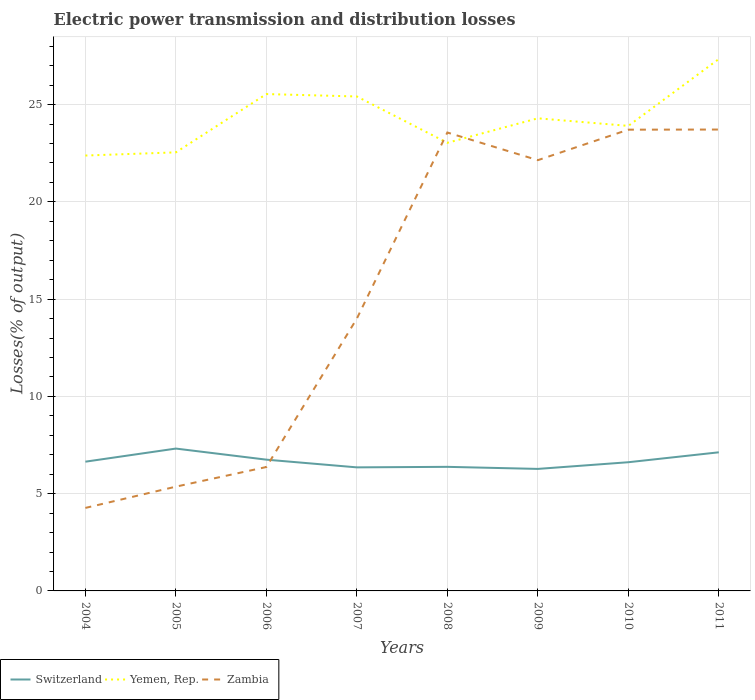How many different coloured lines are there?
Your answer should be very brief. 3. Does the line corresponding to Yemen, Rep. intersect with the line corresponding to Switzerland?
Your response must be concise. No. Is the number of lines equal to the number of legend labels?
Give a very brief answer. Yes. Across all years, what is the maximum electric power transmission and distribution losses in Zambia?
Your answer should be very brief. 4.27. In which year was the electric power transmission and distribution losses in Zambia maximum?
Offer a terse response. 2004. What is the total electric power transmission and distribution losses in Switzerland in the graph?
Provide a short and direct response. -0.67. What is the difference between the highest and the second highest electric power transmission and distribution losses in Zambia?
Offer a terse response. 19.45. Does the graph contain any zero values?
Your answer should be compact. No. How are the legend labels stacked?
Your response must be concise. Horizontal. What is the title of the graph?
Make the answer very short. Electric power transmission and distribution losses. Does "St. Kitts and Nevis" appear as one of the legend labels in the graph?
Give a very brief answer. No. What is the label or title of the Y-axis?
Your answer should be very brief. Losses(% of output). What is the Losses(% of output) in Switzerland in 2004?
Provide a short and direct response. 6.64. What is the Losses(% of output) in Yemen, Rep. in 2004?
Provide a short and direct response. 22.38. What is the Losses(% of output) in Zambia in 2004?
Your response must be concise. 4.27. What is the Losses(% of output) of Switzerland in 2005?
Your answer should be very brief. 7.32. What is the Losses(% of output) of Yemen, Rep. in 2005?
Your response must be concise. 22.55. What is the Losses(% of output) of Zambia in 2005?
Ensure brevity in your answer.  5.36. What is the Losses(% of output) of Switzerland in 2006?
Your answer should be very brief. 6.75. What is the Losses(% of output) in Yemen, Rep. in 2006?
Ensure brevity in your answer.  25.54. What is the Losses(% of output) of Zambia in 2006?
Provide a short and direct response. 6.37. What is the Losses(% of output) in Switzerland in 2007?
Your answer should be compact. 6.35. What is the Losses(% of output) of Yemen, Rep. in 2007?
Ensure brevity in your answer.  25.42. What is the Losses(% of output) in Zambia in 2007?
Provide a short and direct response. 14. What is the Losses(% of output) of Switzerland in 2008?
Make the answer very short. 6.38. What is the Losses(% of output) in Yemen, Rep. in 2008?
Provide a short and direct response. 23.04. What is the Losses(% of output) in Zambia in 2008?
Your answer should be compact. 23.57. What is the Losses(% of output) of Switzerland in 2009?
Your answer should be compact. 6.27. What is the Losses(% of output) of Yemen, Rep. in 2009?
Ensure brevity in your answer.  24.3. What is the Losses(% of output) of Zambia in 2009?
Keep it short and to the point. 22.14. What is the Losses(% of output) of Switzerland in 2010?
Keep it short and to the point. 6.62. What is the Losses(% of output) of Yemen, Rep. in 2010?
Ensure brevity in your answer.  23.91. What is the Losses(% of output) in Zambia in 2010?
Offer a very short reply. 23.71. What is the Losses(% of output) of Switzerland in 2011?
Ensure brevity in your answer.  7.13. What is the Losses(% of output) in Yemen, Rep. in 2011?
Give a very brief answer. 27.34. What is the Losses(% of output) of Zambia in 2011?
Provide a short and direct response. 23.72. Across all years, what is the maximum Losses(% of output) in Switzerland?
Provide a short and direct response. 7.32. Across all years, what is the maximum Losses(% of output) in Yemen, Rep.?
Provide a succinct answer. 27.34. Across all years, what is the maximum Losses(% of output) of Zambia?
Offer a terse response. 23.72. Across all years, what is the minimum Losses(% of output) of Switzerland?
Provide a succinct answer. 6.27. Across all years, what is the minimum Losses(% of output) of Yemen, Rep.?
Ensure brevity in your answer.  22.38. Across all years, what is the minimum Losses(% of output) of Zambia?
Your response must be concise. 4.27. What is the total Losses(% of output) in Switzerland in the graph?
Provide a short and direct response. 53.46. What is the total Losses(% of output) of Yemen, Rep. in the graph?
Your answer should be compact. 194.48. What is the total Losses(% of output) in Zambia in the graph?
Offer a terse response. 123.14. What is the difference between the Losses(% of output) in Switzerland in 2004 and that in 2005?
Your response must be concise. -0.67. What is the difference between the Losses(% of output) of Yemen, Rep. in 2004 and that in 2005?
Make the answer very short. -0.16. What is the difference between the Losses(% of output) in Zambia in 2004 and that in 2005?
Give a very brief answer. -1.09. What is the difference between the Losses(% of output) in Switzerland in 2004 and that in 2006?
Your answer should be compact. -0.1. What is the difference between the Losses(% of output) of Yemen, Rep. in 2004 and that in 2006?
Give a very brief answer. -3.16. What is the difference between the Losses(% of output) of Zambia in 2004 and that in 2006?
Your response must be concise. -2.1. What is the difference between the Losses(% of output) of Switzerland in 2004 and that in 2007?
Make the answer very short. 0.29. What is the difference between the Losses(% of output) of Yemen, Rep. in 2004 and that in 2007?
Give a very brief answer. -3.04. What is the difference between the Losses(% of output) in Zambia in 2004 and that in 2007?
Your response must be concise. -9.74. What is the difference between the Losses(% of output) of Switzerland in 2004 and that in 2008?
Provide a short and direct response. 0.27. What is the difference between the Losses(% of output) of Yemen, Rep. in 2004 and that in 2008?
Give a very brief answer. -0.65. What is the difference between the Losses(% of output) in Zambia in 2004 and that in 2008?
Your answer should be compact. -19.3. What is the difference between the Losses(% of output) in Switzerland in 2004 and that in 2009?
Your response must be concise. 0.37. What is the difference between the Losses(% of output) of Yemen, Rep. in 2004 and that in 2009?
Offer a very short reply. -1.91. What is the difference between the Losses(% of output) in Zambia in 2004 and that in 2009?
Provide a short and direct response. -17.88. What is the difference between the Losses(% of output) of Switzerland in 2004 and that in 2010?
Make the answer very short. 0.03. What is the difference between the Losses(% of output) in Yemen, Rep. in 2004 and that in 2010?
Ensure brevity in your answer.  -1.52. What is the difference between the Losses(% of output) of Zambia in 2004 and that in 2010?
Ensure brevity in your answer.  -19.45. What is the difference between the Losses(% of output) of Switzerland in 2004 and that in 2011?
Provide a short and direct response. -0.48. What is the difference between the Losses(% of output) in Yemen, Rep. in 2004 and that in 2011?
Give a very brief answer. -4.96. What is the difference between the Losses(% of output) in Zambia in 2004 and that in 2011?
Keep it short and to the point. -19.45. What is the difference between the Losses(% of output) of Switzerland in 2005 and that in 2006?
Your response must be concise. 0.57. What is the difference between the Losses(% of output) of Yemen, Rep. in 2005 and that in 2006?
Provide a short and direct response. -3. What is the difference between the Losses(% of output) of Zambia in 2005 and that in 2006?
Keep it short and to the point. -1.01. What is the difference between the Losses(% of output) in Switzerland in 2005 and that in 2007?
Offer a very short reply. 0.97. What is the difference between the Losses(% of output) of Yemen, Rep. in 2005 and that in 2007?
Provide a succinct answer. -2.87. What is the difference between the Losses(% of output) of Zambia in 2005 and that in 2007?
Provide a succinct answer. -8.64. What is the difference between the Losses(% of output) of Switzerland in 2005 and that in 2008?
Keep it short and to the point. 0.94. What is the difference between the Losses(% of output) in Yemen, Rep. in 2005 and that in 2008?
Your answer should be very brief. -0.49. What is the difference between the Losses(% of output) in Zambia in 2005 and that in 2008?
Provide a short and direct response. -18.21. What is the difference between the Losses(% of output) in Switzerland in 2005 and that in 2009?
Provide a short and direct response. 1.05. What is the difference between the Losses(% of output) in Yemen, Rep. in 2005 and that in 2009?
Provide a succinct answer. -1.75. What is the difference between the Losses(% of output) in Zambia in 2005 and that in 2009?
Your answer should be compact. -16.78. What is the difference between the Losses(% of output) in Switzerland in 2005 and that in 2010?
Your response must be concise. 0.7. What is the difference between the Losses(% of output) of Yemen, Rep. in 2005 and that in 2010?
Provide a short and direct response. -1.36. What is the difference between the Losses(% of output) in Zambia in 2005 and that in 2010?
Keep it short and to the point. -18.35. What is the difference between the Losses(% of output) of Switzerland in 2005 and that in 2011?
Provide a short and direct response. 0.19. What is the difference between the Losses(% of output) in Yemen, Rep. in 2005 and that in 2011?
Your answer should be very brief. -4.8. What is the difference between the Losses(% of output) of Zambia in 2005 and that in 2011?
Offer a very short reply. -18.36. What is the difference between the Losses(% of output) in Switzerland in 2006 and that in 2007?
Give a very brief answer. 0.4. What is the difference between the Losses(% of output) in Yemen, Rep. in 2006 and that in 2007?
Your answer should be compact. 0.12. What is the difference between the Losses(% of output) in Zambia in 2006 and that in 2007?
Offer a very short reply. -7.63. What is the difference between the Losses(% of output) of Switzerland in 2006 and that in 2008?
Offer a terse response. 0.37. What is the difference between the Losses(% of output) in Yemen, Rep. in 2006 and that in 2008?
Your answer should be compact. 2.51. What is the difference between the Losses(% of output) in Zambia in 2006 and that in 2008?
Offer a very short reply. -17.2. What is the difference between the Losses(% of output) of Switzerland in 2006 and that in 2009?
Offer a very short reply. 0.48. What is the difference between the Losses(% of output) of Yemen, Rep. in 2006 and that in 2009?
Your answer should be very brief. 1.25. What is the difference between the Losses(% of output) in Zambia in 2006 and that in 2009?
Offer a very short reply. -15.77. What is the difference between the Losses(% of output) in Switzerland in 2006 and that in 2010?
Your answer should be compact. 0.13. What is the difference between the Losses(% of output) of Yemen, Rep. in 2006 and that in 2010?
Ensure brevity in your answer.  1.64. What is the difference between the Losses(% of output) of Zambia in 2006 and that in 2010?
Offer a very short reply. -17.34. What is the difference between the Losses(% of output) of Switzerland in 2006 and that in 2011?
Your answer should be compact. -0.38. What is the difference between the Losses(% of output) of Yemen, Rep. in 2006 and that in 2011?
Make the answer very short. -1.8. What is the difference between the Losses(% of output) in Zambia in 2006 and that in 2011?
Provide a short and direct response. -17.35. What is the difference between the Losses(% of output) of Switzerland in 2007 and that in 2008?
Ensure brevity in your answer.  -0.03. What is the difference between the Losses(% of output) of Yemen, Rep. in 2007 and that in 2008?
Provide a succinct answer. 2.38. What is the difference between the Losses(% of output) in Zambia in 2007 and that in 2008?
Provide a short and direct response. -9.56. What is the difference between the Losses(% of output) in Switzerland in 2007 and that in 2009?
Offer a very short reply. 0.08. What is the difference between the Losses(% of output) of Yemen, Rep. in 2007 and that in 2009?
Provide a succinct answer. 1.12. What is the difference between the Losses(% of output) in Zambia in 2007 and that in 2009?
Keep it short and to the point. -8.14. What is the difference between the Losses(% of output) of Switzerland in 2007 and that in 2010?
Your answer should be compact. -0.26. What is the difference between the Losses(% of output) of Yemen, Rep. in 2007 and that in 2010?
Offer a terse response. 1.51. What is the difference between the Losses(% of output) of Zambia in 2007 and that in 2010?
Ensure brevity in your answer.  -9.71. What is the difference between the Losses(% of output) in Switzerland in 2007 and that in 2011?
Ensure brevity in your answer.  -0.77. What is the difference between the Losses(% of output) of Yemen, Rep. in 2007 and that in 2011?
Keep it short and to the point. -1.93. What is the difference between the Losses(% of output) in Zambia in 2007 and that in 2011?
Provide a succinct answer. -9.72. What is the difference between the Losses(% of output) in Switzerland in 2008 and that in 2009?
Keep it short and to the point. 0.11. What is the difference between the Losses(% of output) of Yemen, Rep. in 2008 and that in 2009?
Offer a very short reply. -1.26. What is the difference between the Losses(% of output) in Zambia in 2008 and that in 2009?
Provide a short and direct response. 1.42. What is the difference between the Losses(% of output) of Switzerland in 2008 and that in 2010?
Offer a terse response. -0.24. What is the difference between the Losses(% of output) of Yemen, Rep. in 2008 and that in 2010?
Give a very brief answer. -0.87. What is the difference between the Losses(% of output) of Zambia in 2008 and that in 2010?
Your answer should be very brief. -0.15. What is the difference between the Losses(% of output) of Switzerland in 2008 and that in 2011?
Ensure brevity in your answer.  -0.75. What is the difference between the Losses(% of output) in Yemen, Rep. in 2008 and that in 2011?
Your answer should be very brief. -4.31. What is the difference between the Losses(% of output) of Zambia in 2008 and that in 2011?
Ensure brevity in your answer.  -0.15. What is the difference between the Losses(% of output) in Switzerland in 2009 and that in 2010?
Your response must be concise. -0.34. What is the difference between the Losses(% of output) of Yemen, Rep. in 2009 and that in 2010?
Keep it short and to the point. 0.39. What is the difference between the Losses(% of output) in Zambia in 2009 and that in 2010?
Provide a succinct answer. -1.57. What is the difference between the Losses(% of output) of Switzerland in 2009 and that in 2011?
Ensure brevity in your answer.  -0.85. What is the difference between the Losses(% of output) of Yemen, Rep. in 2009 and that in 2011?
Keep it short and to the point. -3.05. What is the difference between the Losses(% of output) of Zambia in 2009 and that in 2011?
Keep it short and to the point. -1.57. What is the difference between the Losses(% of output) in Switzerland in 2010 and that in 2011?
Provide a short and direct response. -0.51. What is the difference between the Losses(% of output) in Yemen, Rep. in 2010 and that in 2011?
Give a very brief answer. -3.44. What is the difference between the Losses(% of output) in Zambia in 2010 and that in 2011?
Keep it short and to the point. -0.01. What is the difference between the Losses(% of output) of Switzerland in 2004 and the Losses(% of output) of Yemen, Rep. in 2005?
Your answer should be compact. -15.9. What is the difference between the Losses(% of output) in Switzerland in 2004 and the Losses(% of output) in Zambia in 2005?
Provide a succinct answer. 1.28. What is the difference between the Losses(% of output) of Yemen, Rep. in 2004 and the Losses(% of output) of Zambia in 2005?
Provide a succinct answer. 17.02. What is the difference between the Losses(% of output) in Switzerland in 2004 and the Losses(% of output) in Yemen, Rep. in 2006?
Keep it short and to the point. -18.9. What is the difference between the Losses(% of output) in Switzerland in 2004 and the Losses(% of output) in Zambia in 2006?
Provide a succinct answer. 0.27. What is the difference between the Losses(% of output) of Yemen, Rep. in 2004 and the Losses(% of output) of Zambia in 2006?
Offer a very short reply. 16.01. What is the difference between the Losses(% of output) of Switzerland in 2004 and the Losses(% of output) of Yemen, Rep. in 2007?
Your answer should be very brief. -18.77. What is the difference between the Losses(% of output) in Switzerland in 2004 and the Losses(% of output) in Zambia in 2007?
Ensure brevity in your answer.  -7.36. What is the difference between the Losses(% of output) in Yemen, Rep. in 2004 and the Losses(% of output) in Zambia in 2007?
Your response must be concise. 8.38. What is the difference between the Losses(% of output) in Switzerland in 2004 and the Losses(% of output) in Yemen, Rep. in 2008?
Keep it short and to the point. -16.39. What is the difference between the Losses(% of output) of Switzerland in 2004 and the Losses(% of output) of Zambia in 2008?
Ensure brevity in your answer.  -16.92. What is the difference between the Losses(% of output) in Yemen, Rep. in 2004 and the Losses(% of output) in Zambia in 2008?
Keep it short and to the point. -1.18. What is the difference between the Losses(% of output) in Switzerland in 2004 and the Losses(% of output) in Yemen, Rep. in 2009?
Ensure brevity in your answer.  -17.65. What is the difference between the Losses(% of output) in Switzerland in 2004 and the Losses(% of output) in Zambia in 2009?
Provide a succinct answer. -15.5. What is the difference between the Losses(% of output) in Yemen, Rep. in 2004 and the Losses(% of output) in Zambia in 2009?
Offer a terse response. 0.24. What is the difference between the Losses(% of output) of Switzerland in 2004 and the Losses(% of output) of Yemen, Rep. in 2010?
Give a very brief answer. -17.26. What is the difference between the Losses(% of output) in Switzerland in 2004 and the Losses(% of output) in Zambia in 2010?
Keep it short and to the point. -17.07. What is the difference between the Losses(% of output) of Yemen, Rep. in 2004 and the Losses(% of output) of Zambia in 2010?
Give a very brief answer. -1.33. What is the difference between the Losses(% of output) in Switzerland in 2004 and the Losses(% of output) in Yemen, Rep. in 2011?
Offer a very short reply. -20.7. What is the difference between the Losses(% of output) in Switzerland in 2004 and the Losses(% of output) in Zambia in 2011?
Keep it short and to the point. -17.08. What is the difference between the Losses(% of output) in Yemen, Rep. in 2004 and the Losses(% of output) in Zambia in 2011?
Ensure brevity in your answer.  -1.34. What is the difference between the Losses(% of output) in Switzerland in 2005 and the Losses(% of output) in Yemen, Rep. in 2006?
Your response must be concise. -18.22. What is the difference between the Losses(% of output) in Switzerland in 2005 and the Losses(% of output) in Zambia in 2006?
Your response must be concise. 0.95. What is the difference between the Losses(% of output) of Yemen, Rep. in 2005 and the Losses(% of output) of Zambia in 2006?
Provide a succinct answer. 16.18. What is the difference between the Losses(% of output) in Switzerland in 2005 and the Losses(% of output) in Yemen, Rep. in 2007?
Provide a short and direct response. -18.1. What is the difference between the Losses(% of output) of Switzerland in 2005 and the Losses(% of output) of Zambia in 2007?
Give a very brief answer. -6.68. What is the difference between the Losses(% of output) of Yemen, Rep. in 2005 and the Losses(% of output) of Zambia in 2007?
Your response must be concise. 8.54. What is the difference between the Losses(% of output) in Switzerland in 2005 and the Losses(% of output) in Yemen, Rep. in 2008?
Make the answer very short. -15.72. What is the difference between the Losses(% of output) in Switzerland in 2005 and the Losses(% of output) in Zambia in 2008?
Make the answer very short. -16.25. What is the difference between the Losses(% of output) in Yemen, Rep. in 2005 and the Losses(% of output) in Zambia in 2008?
Provide a succinct answer. -1.02. What is the difference between the Losses(% of output) in Switzerland in 2005 and the Losses(% of output) in Yemen, Rep. in 2009?
Your response must be concise. -16.98. What is the difference between the Losses(% of output) in Switzerland in 2005 and the Losses(% of output) in Zambia in 2009?
Your answer should be very brief. -14.83. What is the difference between the Losses(% of output) of Yemen, Rep. in 2005 and the Losses(% of output) of Zambia in 2009?
Provide a succinct answer. 0.4. What is the difference between the Losses(% of output) in Switzerland in 2005 and the Losses(% of output) in Yemen, Rep. in 2010?
Give a very brief answer. -16.59. What is the difference between the Losses(% of output) in Switzerland in 2005 and the Losses(% of output) in Zambia in 2010?
Your answer should be very brief. -16.39. What is the difference between the Losses(% of output) of Yemen, Rep. in 2005 and the Losses(% of output) of Zambia in 2010?
Your answer should be compact. -1.17. What is the difference between the Losses(% of output) of Switzerland in 2005 and the Losses(% of output) of Yemen, Rep. in 2011?
Offer a very short reply. -20.03. What is the difference between the Losses(% of output) of Switzerland in 2005 and the Losses(% of output) of Zambia in 2011?
Your answer should be very brief. -16.4. What is the difference between the Losses(% of output) in Yemen, Rep. in 2005 and the Losses(% of output) in Zambia in 2011?
Offer a terse response. -1.17. What is the difference between the Losses(% of output) of Switzerland in 2006 and the Losses(% of output) of Yemen, Rep. in 2007?
Offer a very short reply. -18.67. What is the difference between the Losses(% of output) in Switzerland in 2006 and the Losses(% of output) in Zambia in 2007?
Make the answer very short. -7.25. What is the difference between the Losses(% of output) in Yemen, Rep. in 2006 and the Losses(% of output) in Zambia in 2007?
Your answer should be compact. 11.54. What is the difference between the Losses(% of output) in Switzerland in 2006 and the Losses(% of output) in Yemen, Rep. in 2008?
Give a very brief answer. -16.29. What is the difference between the Losses(% of output) of Switzerland in 2006 and the Losses(% of output) of Zambia in 2008?
Your response must be concise. -16.82. What is the difference between the Losses(% of output) in Yemen, Rep. in 2006 and the Losses(% of output) in Zambia in 2008?
Provide a succinct answer. 1.98. What is the difference between the Losses(% of output) in Switzerland in 2006 and the Losses(% of output) in Yemen, Rep. in 2009?
Your answer should be very brief. -17.55. What is the difference between the Losses(% of output) in Switzerland in 2006 and the Losses(% of output) in Zambia in 2009?
Make the answer very short. -15.4. What is the difference between the Losses(% of output) in Yemen, Rep. in 2006 and the Losses(% of output) in Zambia in 2009?
Ensure brevity in your answer.  3.4. What is the difference between the Losses(% of output) of Switzerland in 2006 and the Losses(% of output) of Yemen, Rep. in 2010?
Your answer should be compact. -17.16. What is the difference between the Losses(% of output) of Switzerland in 2006 and the Losses(% of output) of Zambia in 2010?
Your response must be concise. -16.96. What is the difference between the Losses(% of output) of Yemen, Rep. in 2006 and the Losses(% of output) of Zambia in 2010?
Provide a short and direct response. 1.83. What is the difference between the Losses(% of output) of Switzerland in 2006 and the Losses(% of output) of Yemen, Rep. in 2011?
Provide a succinct answer. -20.6. What is the difference between the Losses(% of output) of Switzerland in 2006 and the Losses(% of output) of Zambia in 2011?
Ensure brevity in your answer.  -16.97. What is the difference between the Losses(% of output) in Yemen, Rep. in 2006 and the Losses(% of output) in Zambia in 2011?
Offer a terse response. 1.82. What is the difference between the Losses(% of output) of Switzerland in 2007 and the Losses(% of output) of Yemen, Rep. in 2008?
Keep it short and to the point. -16.69. What is the difference between the Losses(% of output) in Switzerland in 2007 and the Losses(% of output) in Zambia in 2008?
Offer a terse response. -17.21. What is the difference between the Losses(% of output) of Yemen, Rep. in 2007 and the Losses(% of output) of Zambia in 2008?
Your answer should be very brief. 1.85. What is the difference between the Losses(% of output) of Switzerland in 2007 and the Losses(% of output) of Yemen, Rep. in 2009?
Ensure brevity in your answer.  -17.94. What is the difference between the Losses(% of output) in Switzerland in 2007 and the Losses(% of output) in Zambia in 2009?
Offer a terse response. -15.79. What is the difference between the Losses(% of output) in Yemen, Rep. in 2007 and the Losses(% of output) in Zambia in 2009?
Keep it short and to the point. 3.27. What is the difference between the Losses(% of output) of Switzerland in 2007 and the Losses(% of output) of Yemen, Rep. in 2010?
Offer a very short reply. -17.56. What is the difference between the Losses(% of output) of Switzerland in 2007 and the Losses(% of output) of Zambia in 2010?
Your response must be concise. -17.36. What is the difference between the Losses(% of output) in Yemen, Rep. in 2007 and the Losses(% of output) in Zambia in 2010?
Your answer should be compact. 1.71. What is the difference between the Losses(% of output) of Switzerland in 2007 and the Losses(% of output) of Yemen, Rep. in 2011?
Your response must be concise. -20.99. What is the difference between the Losses(% of output) of Switzerland in 2007 and the Losses(% of output) of Zambia in 2011?
Offer a very short reply. -17.37. What is the difference between the Losses(% of output) in Yemen, Rep. in 2007 and the Losses(% of output) in Zambia in 2011?
Keep it short and to the point. 1.7. What is the difference between the Losses(% of output) in Switzerland in 2008 and the Losses(% of output) in Yemen, Rep. in 2009?
Ensure brevity in your answer.  -17.92. What is the difference between the Losses(% of output) in Switzerland in 2008 and the Losses(% of output) in Zambia in 2009?
Your answer should be compact. -15.77. What is the difference between the Losses(% of output) of Yemen, Rep. in 2008 and the Losses(% of output) of Zambia in 2009?
Give a very brief answer. 0.89. What is the difference between the Losses(% of output) of Switzerland in 2008 and the Losses(% of output) of Yemen, Rep. in 2010?
Offer a terse response. -17.53. What is the difference between the Losses(% of output) in Switzerland in 2008 and the Losses(% of output) in Zambia in 2010?
Your answer should be very brief. -17.33. What is the difference between the Losses(% of output) of Yemen, Rep. in 2008 and the Losses(% of output) of Zambia in 2010?
Make the answer very short. -0.68. What is the difference between the Losses(% of output) in Switzerland in 2008 and the Losses(% of output) in Yemen, Rep. in 2011?
Offer a terse response. -20.97. What is the difference between the Losses(% of output) of Switzerland in 2008 and the Losses(% of output) of Zambia in 2011?
Provide a short and direct response. -17.34. What is the difference between the Losses(% of output) in Yemen, Rep. in 2008 and the Losses(% of output) in Zambia in 2011?
Your response must be concise. -0.68. What is the difference between the Losses(% of output) in Switzerland in 2009 and the Losses(% of output) in Yemen, Rep. in 2010?
Provide a succinct answer. -17.63. What is the difference between the Losses(% of output) in Switzerland in 2009 and the Losses(% of output) in Zambia in 2010?
Offer a terse response. -17.44. What is the difference between the Losses(% of output) in Yemen, Rep. in 2009 and the Losses(% of output) in Zambia in 2010?
Your answer should be very brief. 0.58. What is the difference between the Losses(% of output) of Switzerland in 2009 and the Losses(% of output) of Yemen, Rep. in 2011?
Make the answer very short. -21.07. What is the difference between the Losses(% of output) of Switzerland in 2009 and the Losses(% of output) of Zambia in 2011?
Provide a short and direct response. -17.45. What is the difference between the Losses(% of output) of Yemen, Rep. in 2009 and the Losses(% of output) of Zambia in 2011?
Make the answer very short. 0.58. What is the difference between the Losses(% of output) of Switzerland in 2010 and the Losses(% of output) of Yemen, Rep. in 2011?
Provide a short and direct response. -20.73. What is the difference between the Losses(% of output) in Switzerland in 2010 and the Losses(% of output) in Zambia in 2011?
Give a very brief answer. -17.1. What is the difference between the Losses(% of output) in Yemen, Rep. in 2010 and the Losses(% of output) in Zambia in 2011?
Keep it short and to the point. 0.19. What is the average Losses(% of output) of Switzerland per year?
Your answer should be very brief. 6.68. What is the average Losses(% of output) of Yemen, Rep. per year?
Ensure brevity in your answer.  24.31. What is the average Losses(% of output) of Zambia per year?
Provide a short and direct response. 15.39. In the year 2004, what is the difference between the Losses(% of output) in Switzerland and Losses(% of output) in Yemen, Rep.?
Provide a succinct answer. -15.74. In the year 2004, what is the difference between the Losses(% of output) of Switzerland and Losses(% of output) of Zambia?
Give a very brief answer. 2.38. In the year 2004, what is the difference between the Losses(% of output) in Yemen, Rep. and Losses(% of output) in Zambia?
Provide a short and direct response. 18.12. In the year 2005, what is the difference between the Losses(% of output) in Switzerland and Losses(% of output) in Yemen, Rep.?
Give a very brief answer. -15.23. In the year 2005, what is the difference between the Losses(% of output) of Switzerland and Losses(% of output) of Zambia?
Keep it short and to the point. 1.96. In the year 2005, what is the difference between the Losses(% of output) in Yemen, Rep. and Losses(% of output) in Zambia?
Offer a very short reply. 17.19. In the year 2006, what is the difference between the Losses(% of output) of Switzerland and Losses(% of output) of Yemen, Rep.?
Offer a very short reply. -18.79. In the year 2006, what is the difference between the Losses(% of output) in Switzerland and Losses(% of output) in Zambia?
Make the answer very short. 0.38. In the year 2006, what is the difference between the Losses(% of output) in Yemen, Rep. and Losses(% of output) in Zambia?
Make the answer very short. 19.17. In the year 2007, what is the difference between the Losses(% of output) of Switzerland and Losses(% of output) of Yemen, Rep.?
Keep it short and to the point. -19.07. In the year 2007, what is the difference between the Losses(% of output) of Switzerland and Losses(% of output) of Zambia?
Your response must be concise. -7.65. In the year 2007, what is the difference between the Losses(% of output) in Yemen, Rep. and Losses(% of output) in Zambia?
Make the answer very short. 11.42. In the year 2008, what is the difference between the Losses(% of output) of Switzerland and Losses(% of output) of Yemen, Rep.?
Your answer should be compact. -16.66. In the year 2008, what is the difference between the Losses(% of output) in Switzerland and Losses(% of output) in Zambia?
Provide a short and direct response. -17.19. In the year 2008, what is the difference between the Losses(% of output) in Yemen, Rep. and Losses(% of output) in Zambia?
Provide a succinct answer. -0.53. In the year 2009, what is the difference between the Losses(% of output) of Switzerland and Losses(% of output) of Yemen, Rep.?
Make the answer very short. -18.02. In the year 2009, what is the difference between the Losses(% of output) of Switzerland and Losses(% of output) of Zambia?
Make the answer very short. -15.87. In the year 2009, what is the difference between the Losses(% of output) in Yemen, Rep. and Losses(% of output) in Zambia?
Keep it short and to the point. 2.15. In the year 2010, what is the difference between the Losses(% of output) in Switzerland and Losses(% of output) in Yemen, Rep.?
Provide a short and direct response. -17.29. In the year 2010, what is the difference between the Losses(% of output) of Switzerland and Losses(% of output) of Zambia?
Ensure brevity in your answer.  -17.1. In the year 2010, what is the difference between the Losses(% of output) of Yemen, Rep. and Losses(% of output) of Zambia?
Your answer should be very brief. 0.19. In the year 2011, what is the difference between the Losses(% of output) in Switzerland and Losses(% of output) in Yemen, Rep.?
Your answer should be compact. -20.22. In the year 2011, what is the difference between the Losses(% of output) of Switzerland and Losses(% of output) of Zambia?
Provide a succinct answer. -16.59. In the year 2011, what is the difference between the Losses(% of output) in Yemen, Rep. and Losses(% of output) in Zambia?
Offer a terse response. 3.63. What is the ratio of the Losses(% of output) in Switzerland in 2004 to that in 2005?
Your response must be concise. 0.91. What is the ratio of the Losses(% of output) in Yemen, Rep. in 2004 to that in 2005?
Ensure brevity in your answer.  0.99. What is the ratio of the Losses(% of output) in Zambia in 2004 to that in 2005?
Keep it short and to the point. 0.8. What is the ratio of the Losses(% of output) in Switzerland in 2004 to that in 2006?
Keep it short and to the point. 0.98. What is the ratio of the Losses(% of output) in Yemen, Rep. in 2004 to that in 2006?
Your response must be concise. 0.88. What is the ratio of the Losses(% of output) of Zambia in 2004 to that in 2006?
Your response must be concise. 0.67. What is the ratio of the Losses(% of output) in Switzerland in 2004 to that in 2007?
Offer a very short reply. 1.05. What is the ratio of the Losses(% of output) of Yemen, Rep. in 2004 to that in 2007?
Offer a very short reply. 0.88. What is the ratio of the Losses(% of output) in Zambia in 2004 to that in 2007?
Give a very brief answer. 0.3. What is the ratio of the Losses(% of output) of Switzerland in 2004 to that in 2008?
Offer a very short reply. 1.04. What is the ratio of the Losses(% of output) of Yemen, Rep. in 2004 to that in 2008?
Ensure brevity in your answer.  0.97. What is the ratio of the Losses(% of output) of Zambia in 2004 to that in 2008?
Give a very brief answer. 0.18. What is the ratio of the Losses(% of output) in Switzerland in 2004 to that in 2009?
Your response must be concise. 1.06. What is the ratio of the Losses(% of output) in Yemen, Rep. in 2004 to that in 2009?
Your answer should be compact. 0.92. What is the ratio of the Losses(% of output) of Zambia in 2004 to that in 2009?
Ensure brevity in your answer.  0.19. What is the ratio of the Losses(% of output) of Switzerland in 2004 to that in 2010?
Keep it short and to the point. 1. What is the ratio of the Losses(% of output) of Yemen, Rep. in 2004 to that in 2010?
Your answer should be very brief. 0.94. What is the ratio of the Losses(% of output) of Zambia in 2004 to that in 2010?
Offer a terse response. 0.18. What is the ratio of the Losses(% of output) in Switzerland in 2004 to that in 2011?
Provide a succinct answer. 0.93. What is the ratio of the Losses(% of output) of Yemen, Rep. in 2004 to that in 2011?
Your response must be concise. 0.82. What is the ratio of the Losses(% of output) in Zambia in 2004 to that in 2011?
Ensure brevity in your answer.  0.18. What is the ratio of the Losses(% of output) of Switzerland in 2005 to that in 2006?
Your response must be concise. 1.08. What is the ratio of the Losses(% of output) in Yemen, Rep. in 2005 to that in 2006?
Give a very brief answer. 0.88. What is the ratio of the Losses(% of output) of Zambia in 2005 to that in 2006?
Your answer should be very brief. 0.84. What is the ratio of the Losses(% of output) in Switzerland in 2005 to that in 2007?
Your answer should be compact. 1.15. What is the ratio of the Losses(% of output) of Yemen, Rep. in 2005 to that in 2007?
Your answer should be compact. 0.89. What is the ratio of the Losses(% of output) in Zambia in 2005 to that in 2007?
Your answer should be compact. 0.38. What is the ratio of the Losses(% of output) in Switzerland in 2005 to that in 2008?
Keep it short and to the point. 1.15. What is the ratio of the Losses(% of output) in Yemen, Rep. in 2005 to that in 2008?
Keep it short and to the point. 0.98. What is the ratio of the Losses(% of output) in Zambia in 2005 to that in 2008?
Your response must be concise. 0.23. What is the ratio of the Losses(% of output) of Yemen, Rep. in 2005 to that in 2009?
Your answer should be compact. 0.93. What is the ratio of the Losses(% of output) in Zambia in 2005 to that in 2009?
Provide a succinct answer. 0.24. What is the ratio of the Losses(% of output) of Switzerland in 2005 to that in 2010?
Provide a succinct answer. 1.11. What is the ratio of the Losses(% of output) in Yemen, Rep. in 2005 to that in 2010?
Offer a terse response. 0.94. What is the ratio of the Losses(% of output) of Zambia in 2005 to that in 2010?
Keep it short and to the point. 0.23. What is the ratio of the Losses(% of output) of Switzerland in 2005 to that in 2011?
Keep it short and to the point. 1.03. What is the ratio of the Losses(% of output) of Yemen, Rep. in 2005 to that in 2011?
Offer a terse response. 0.82. What is the ratio of the Losses(% of output) in Zambia in 2005 to that in 2011?
Make the answer very short. 0.23. What is the ratio of the Losses(% of output) of Switzerland in 2006 to that in 2007?
Your answer should be compact. 1.06. What is the ratio of the Losses(% of output) of Yemen, Rep. in 2006 to that in 2007?
Your answer should be compact. 1. What is the ratio of the Losses(% of output) in Zambia in 2006 to that in 2007?
Give a very brief answer. 0.45. What is the ratio of the Losses(% of output) of Switzerland in 2006 to that in 2008?
Provide a short and direct response. 1.06. What is the ratio of the Losses(% of output) of Yemen, Rep. in 2006 to that in 2008?
Keep it short and to the point. 1.11. What is the ratio of the Losses(% of output) of Zambia in 2006 to that in 2008?
Your answer should be very brief. 0.27. What is the ratio of the Losses(% of output) in Switzerland in 2006 to that in 2009?
Your answer should be very brief. 1.08. What is the ratio of the Losses(% of output) of Yemen, Rep. in 2006 to that in 2009?
Your answer should be very brief. 1.05. What is the ratio of the Losses(% of output) in Zambia in 2006 to that in 2009?
Your answer should be very brief. 0.29. What is the ratio of the Losses(% of output) of Yemen, Rep. in 2006 to that in 2010?
Make the answer very short. 1.07. What is the ratio of the Losses(% of output) of Zambia in 2006 to that in 2010?
Provide a short and direct response. 0.27. What is the ratio of the Losses(% of output) of Switzerland in 2006 to that in 2011?
Ensure brevity in your answer.  0.95. What is the ratio of the Losses(% of output) in Yemen, Rep. in 2006 to that in 2011?
Ensure brevity in your answer.  0.93. What is the ratio of the Losses(% of output) in Zambia in 2006 to that in 2011?
Make the answer very short. 0.27. What is the ratio of the Losses(% of output) in Switzerland in 2007 to that in 2008?
Provide a succinct answer. 1. What is the ratio of the Losses(% of output) in Yemen, Rep. in 2007 to that in 2008?
Make the answer very short. 1.1. What is the ratio of the Losses(% of output) of Zambia in 2007 to that in 2008?
Provide a short and direct response. 0.59. What is the ratio of the Losses(% of output) in Switzerland in 2007 to that in 2009?
Your response must be concise. 1.01. What is the ratio of the Losses(% of output) in Yemen, Rep. in 2007 to that in 2009?
Provide a short and direct response. 1.05. What is the ratio of the Losses(% of output) of Zambia in 2007 to that in 2009?
Your answer should be compact. 0.63. What is the ratio of the Losses(% of output) in Switzerland in 2007 to that in 2010?
Provide a succinct answer. 0.96. What is the ratio of the Losses(% of output) in Yemen, Rep. in 2007 to that in 2010?
Offer a very short reply. 1.06. What is the ratio of the Losses(% of output) in Zambia in 2007 to that in 2010?
Your answer should be compact. 0.59. What is the ratio of the Losses(% of output) in Switzerland in 2007 to that in 2011?
Your answer should be compact. 0.89. What is the ratio of the Losses(% of output) in Yemen, Rep. in 2007 to that in 2011?
Your answer should be compact. 0.93. What is the ratio of the Losses(% of output) of Zambia in 2007 to that in 2011?
Make the answer very short. 0.59. What is the ratio of the Losses(% of output) of Switzerland in 2008 to that in 2009?
Provide a short and direct response. 1.02. What is the ratio of the Losses(% of output) of Yemen, Rep. in 2008 to that in 2009?
Provide a short and direct response. 0.95. What is the ratio of the Losses(% of output) in Zambia in 2008 to that in 2009?
Your response must be concise. 1.06. What is the ratio of the Losses(% of output) of Switzerland in 2008 to that in 2010?
Make the answer very short. 0.96. What is the ratio of the Losses(% of output) in Yemen, Rep. in 2008 to that in 2010?
Your answer should be compact. 0.96. What is the ratio of the Losses(% of output) in Switzerland in 2008 to that in 2011?
Your answer should be very brief. 0.9. What is the ratio of the Losses(% of output) in Yemen, Rep. in 2008 to that in 2011?
Provide a succinct answer. 0.84. What is the ratio of the Losses(% of output) of Zambia in 2008 to that in 2011?
Offer a very short reply. 0.99. What is the ratio of the Losses(% of output) in Switzerland in 2009 to that in 2010?
Your answer should be very brief. 0.95. What is the ratio of the Losses(% of output) of Yemen, Rep. in 2009 to that in 2010?
Ensure brevity in your answer.  1.02. What is the ratio of the Losses(% of output) of Zambia in 2009 to that in 2010?
Give a very brief answer. 0.93. What is the ratio of the Losses(% of output) in Switzerland in 2009 to that in 2011?
Your answer should be very brief. 0.88. What is the ratio of the Losses(% of output) of Yemen, Rep. in 2009 to that in 2011?
Offer a terse response. 0.89. What is the ratio of the Losses(% of output) of Zambia in 2009 to that in 2011?
Keep it short and to the point. 0.93. What is the ratio of the Losses(% of output) of Switzerland in 2010 to that in 2011?
Make the answer very short. 0.93. What is the ratio of the Losses(% of output) of Yemen, Rep. in 2010 to that in 2011?
Ensure brevity in your answer.  0.87. What is the difference between the highest and the second highest Losses(% of output) of Switzerland?
Offer a terse response. 0.19. What is the difference between the highest and the second highest Losses(% of output) of Yemen, Rep.?
Give a very brief answer. 1.8. What is the difference between the highest and the second highest Losses(% of output) in Zambia?
Offer a terse response. 0.01. What is the difference between the highest and the lowest Losses(% of output) in Switzerland?
Your answer should be compact. 1.05. What is the difference between the highest and the lowest Losses(% of output) of Yemen, Rep.?
Your answer should be compact. 4.96. What is the difference between the highest and the lowest Losses(% of output) of Zambia?
Give a very brief answer. 19.45. 